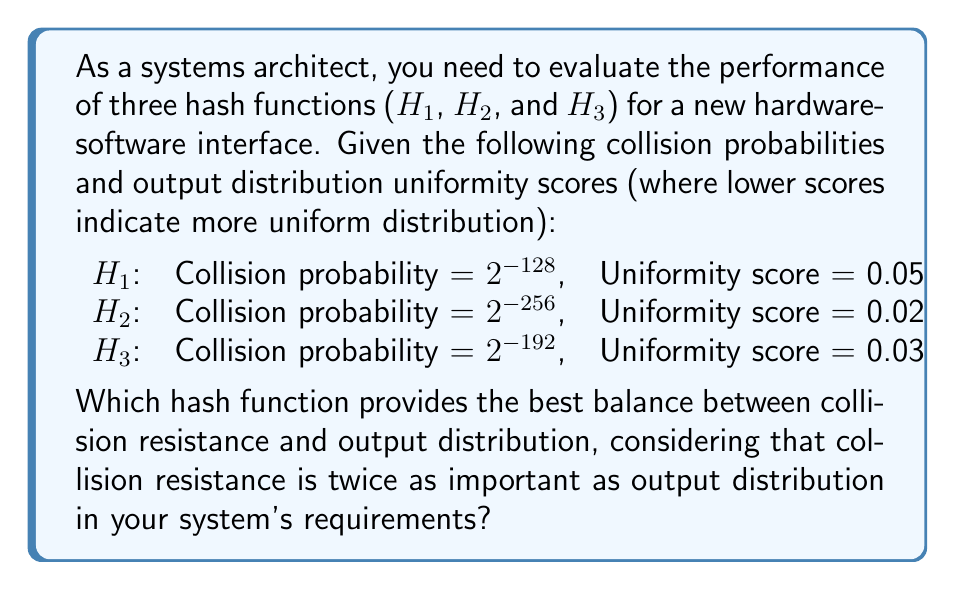Give your solution to this math problem. To solve this problem, we need to follow these steps:

1. Understand the metrics:
   - Collision resistance is measured by the collision probability (lower is better)
   - Output distribution is measured by the uniformity score (lower is better)

2. Normalize the collision probabilities:
   Let's convert the collision probabilities to a scale where higher is better:
   H1: $-\log_2(2^{-128}) = 128$
   H2: $-\log_2(2^{-256}) = 256$
   H3: $-\log_2(2^{-192}) = 192$

3. Normalize the uniformity scores:
   We'll invert the scores so that higher is better:
   H1: $1 / 0.05 = 20$
   H2: $1 / 0.02 = 50$
   H3: $1 / 0.03 = 33.33$

4. Create a weighted score:
   Given that collision resistance is twice as important, we'll use weights of 2 and 1:
   Score = (2 * Normalized Collision Resistance + 1 * Normalized Uniformity) / 3

5. Calculate the weighted scores:
   H1: $(2 * 128 + 1 * 20) / 3 = 92$
   H2: $(2 * 256 + 1 * 50) / 3 = 187.33$
   H3: $(2 * 192 + 1 * 33.33) / 3 = 139.11$

6. Compare the scores:
   H2 has the highest score (187.33), followed by H3 (139.11), then H1 (92).

Therefore, H2 provides the best balance between collision resistance and output distribution for the given requirements.
Answer: H2 